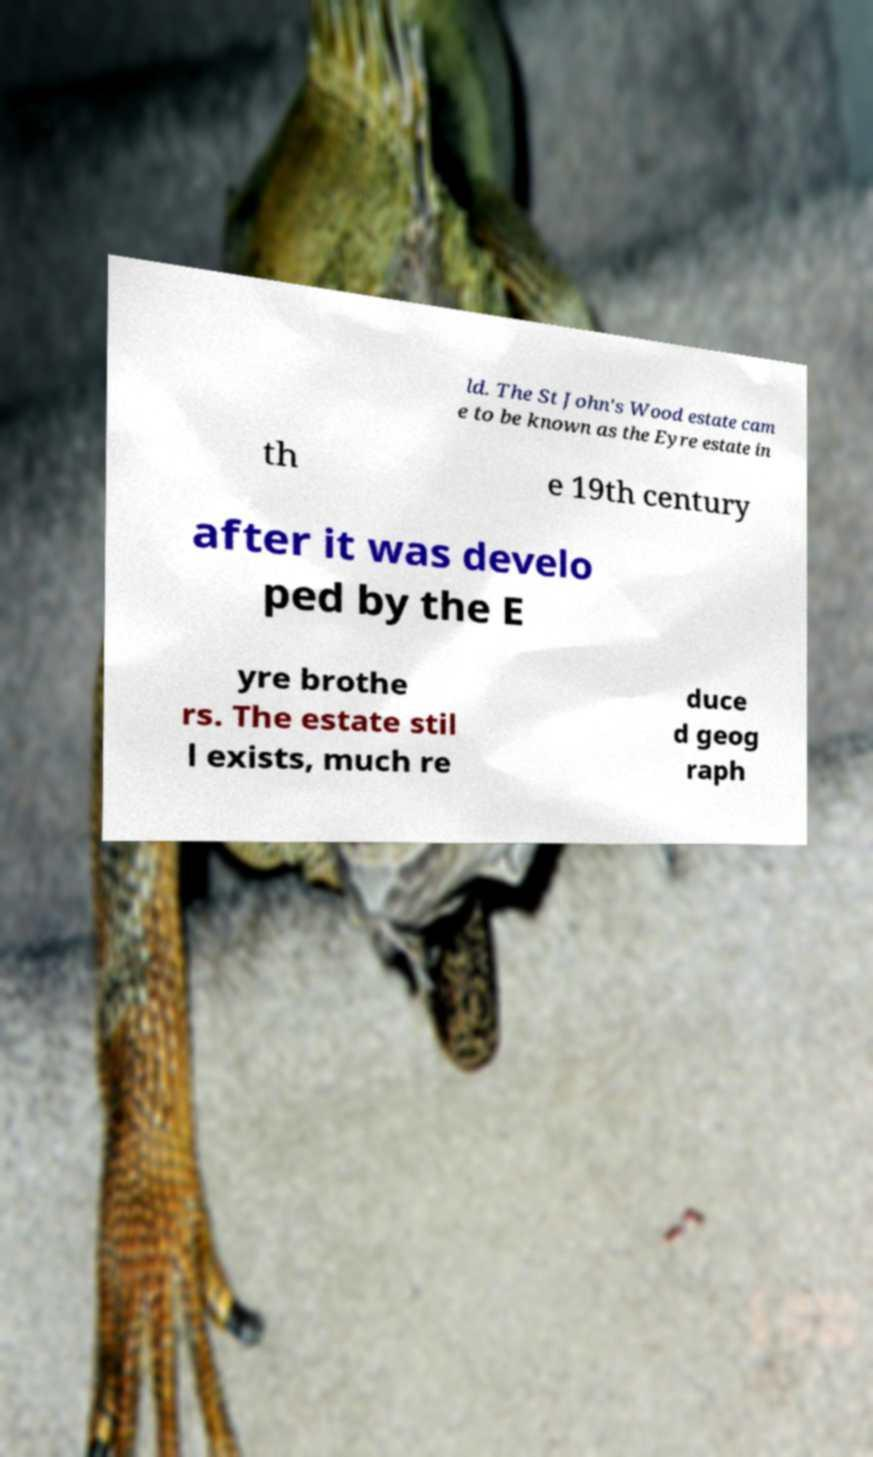For documentation purposes, I need the text within this image transcribed. Could you provide that? ld. The St John's Wood estate cam e to be known as the Eyre estate in th e 19th century after it was develo ped by the E yre brothe rs. The estate stil l exists, much re duce d geog raph 